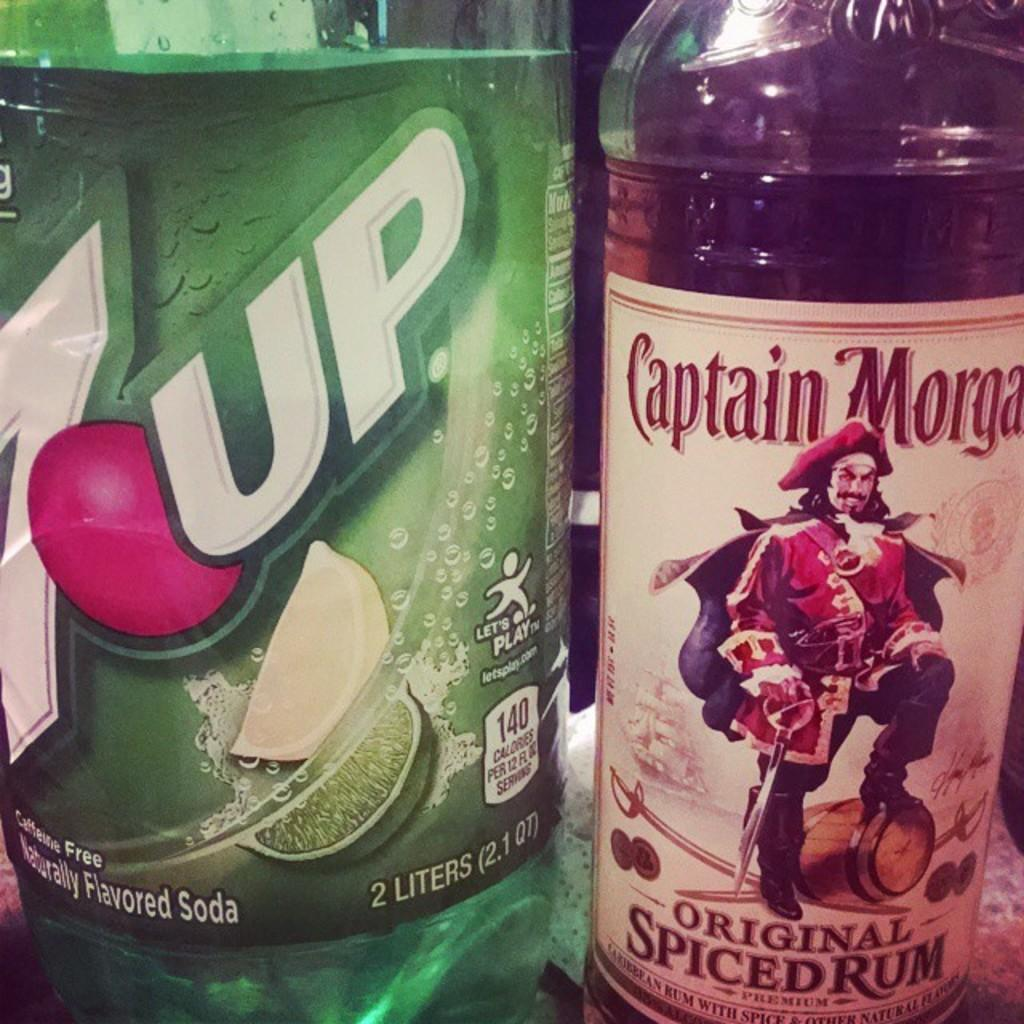<image>
Present a compact description of the photo's key features. A 2 liter bottle of 7 Up is on a counter by a bottle of Captain Morgan. 